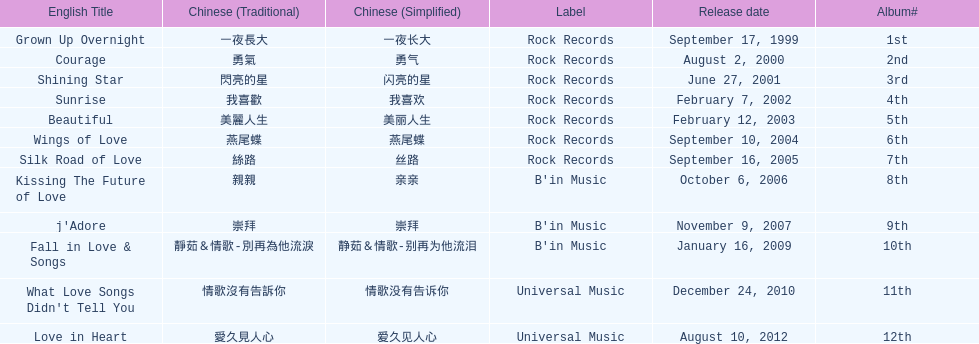What is the name of her last album produced with rock records? Silk Road of Love. 